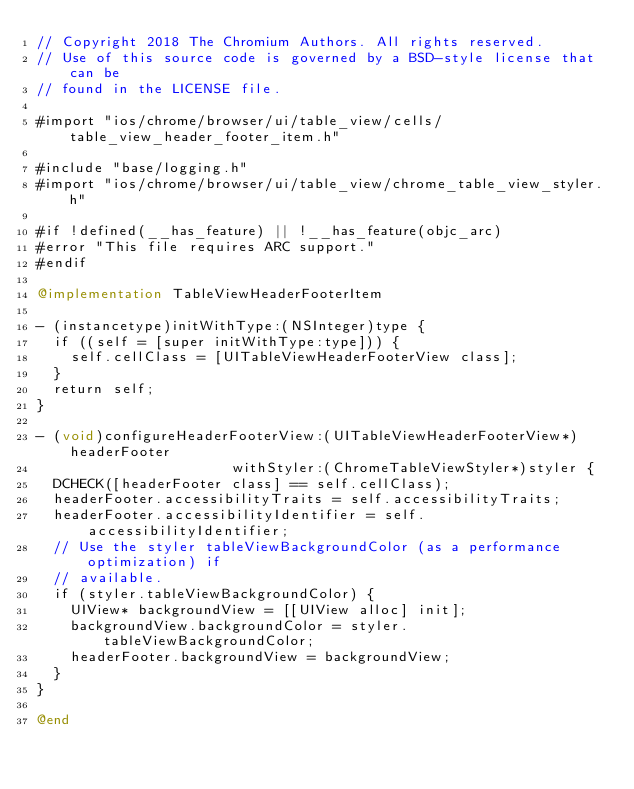Convert code to text. <code><loc_0><loc_0><loc_500><loc_500><_ObjectiveC_>// Copyright 2018 The Chromium Authors. All rights reserved.
// Use of this source code is governed by a BSD-style license that can be
// found in the LICENSE file.

#import "ios/chrome/browser/ui/table_view/cells/table_view_header_footer_item.h"

#include "base/logging.h"
#import "ios/chrome/browser/ui/table_view/chrome_table_view_styler.h"

#if !defined(__has_feature) || !__has_feature(objc_arc)
#error "This file requires ARC support."
#endif

@implementation TableViewHeaderFooterItem

- (instancetype)initWithType:(NSInteger)type {
  if ((self = [super initWithType:type])) {
    self.cellClass = [UITableViewHeaderFooterView class];
  }
  return self;
}

- (void)configureHeaderFooterView:(UITableViewHeaderFooterView*)headerFooter
                       withStyler:(ChromeTableViewStyler*)styler {
  DCHECK([headerFooter class] == self.cellClass);
  headerFooter.accessibilityTraits = self.accessibilityTraits;
  headerFooter.accessibilityIdentifier = self.accessibilityIdentifier;
  // Use the styler tableViewBackgroundColor (as a performance optimization) if
  // available.
  if (styler.tableViewBackgroundColor) {
    UIView* backgroundView = [[UIView alloc] init];
    backgroundView.backgroundColor = styler.tableViewBackgroundColor;
    headerFooter.backgroundView = backgroundView;
  }
}

@end
</code> 